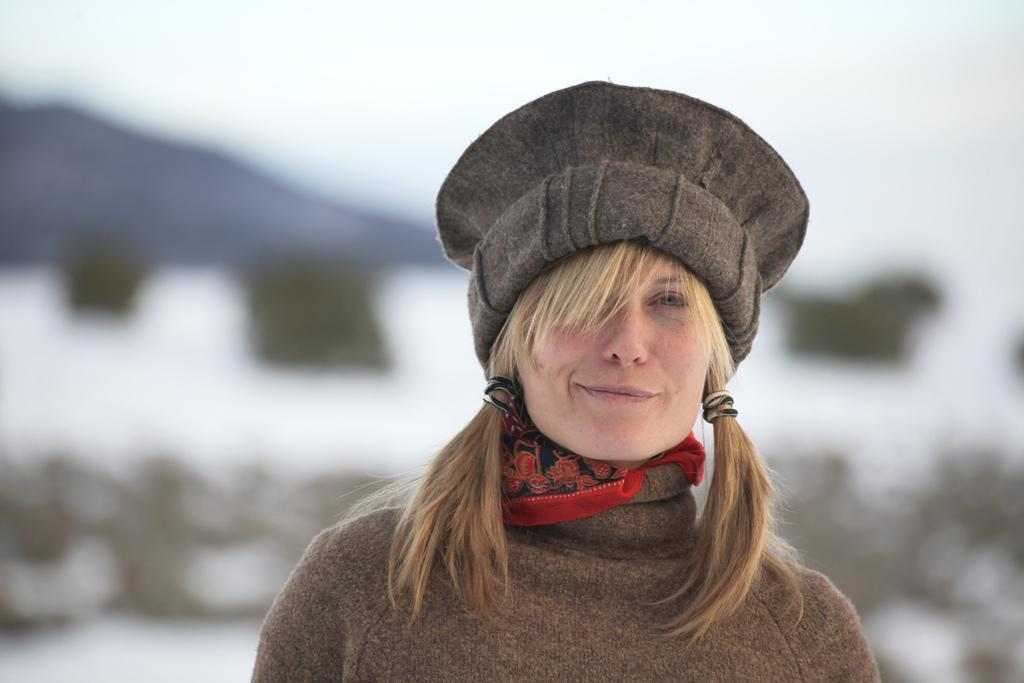Who is the main subject in the foreground of the image? There is a woman in the foreground of the image. What is the woman wearing on her head? The woman is wearing a hat. What can be seen in the background of the image? The sky is visible in the background of the image. When was the image taken? The image was taken during the day. How many brothers can be seen swimming in the lake in the image? There is no lake or brothers present in the image; it features a woman wearing a hat in the foreground. 